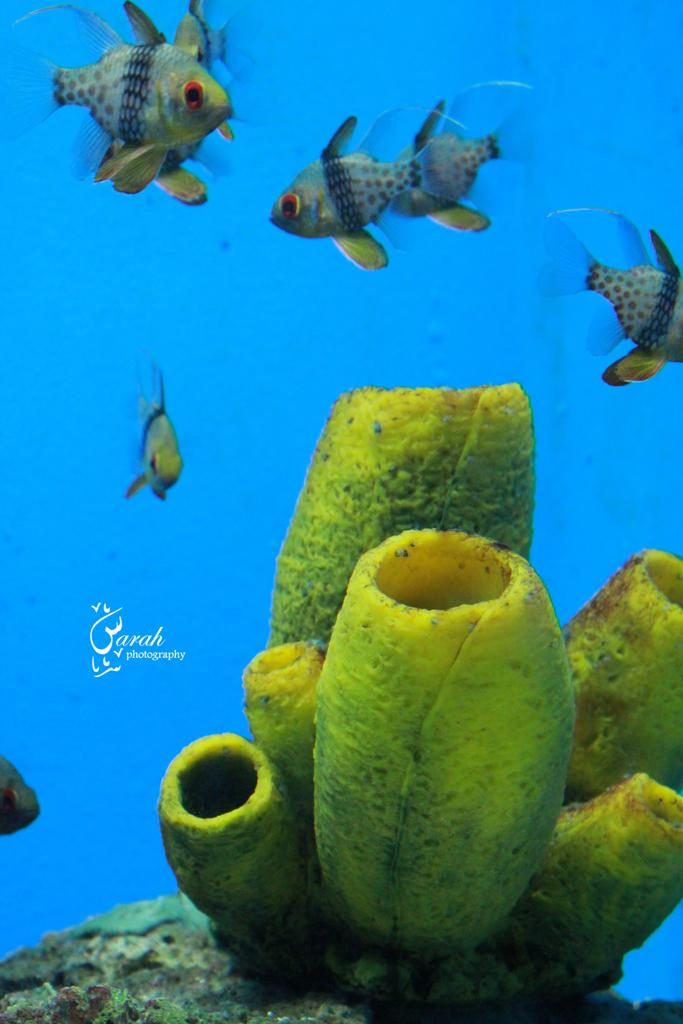What is the setting of the image? The image is taken underwater. What types of marine life can be seen in the image? There are fishes in the image. Are there any plants visible in the image? Yes, there appears to be a plant in the image. Is there any text present in the image? Yes, there is some text on the image. What type of dress is being worn by the fish in the image? There is no dress present in the image, as it is taken underwater and features marine life. 